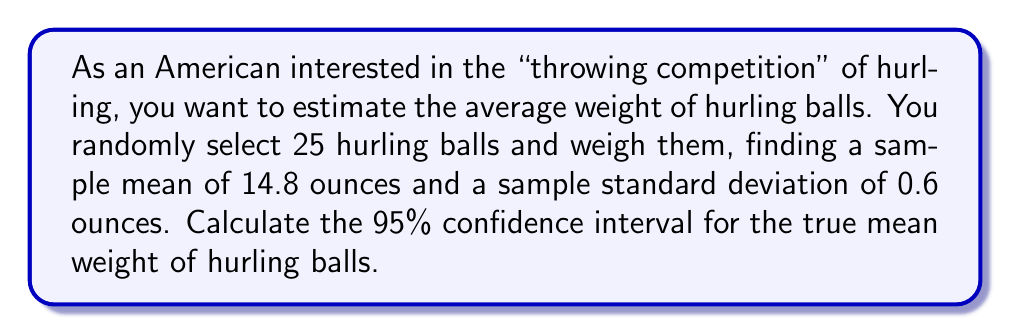Can you solve this math problem? Let's calculate the confidence interval step-by-step:

1) We are given:
   - Sample size: $n = 25$
   - Sample mean: $\bar{x} = 14.8$ ounces
   - Sample standard deviation: $s = 0.6$ ounces
   - Confidence level: 95% (α = 0.05)

2) For a 95% confidence interval with 24 degrees of freedom (n-1), the t-value is approximately 2.064. We can denote this as $t_{0.025, 24}= 2.064$.

3) The formula for the confidence interval is:

   $$ \text{CI} = \bar{x} \pm t_{\alpha/2, n-1} \cdot \frac{s}{\sqrt{n}} $$

4) Let's calculate the margin of error:

   $$ \text{Margin of Error} = t_{0.025, 24} \cdot \frac{s}{\sqrt{n}} = 2.064 \cdot \frac{0.6}{\sqrt{25}} = 0.2477 $$

5) Now, we can calculate the lower and upper bounds of the confidence interval:

   Lower bound: $14.8 - 0.2477 = 14.5523$
   Upper bound: $14.8 + 0.2477 = 15.0477$

6) Rounding to two decimal places for practical purposes:

   $$ \text{95% CI} = (14.55, 15.05) \text{ ounces} $$

This means we can be 95% confident that the true mean weight of hurling balls falls between 14.55 and 15.05 ounces.
Answer: (14.55, 15.05) ounces 